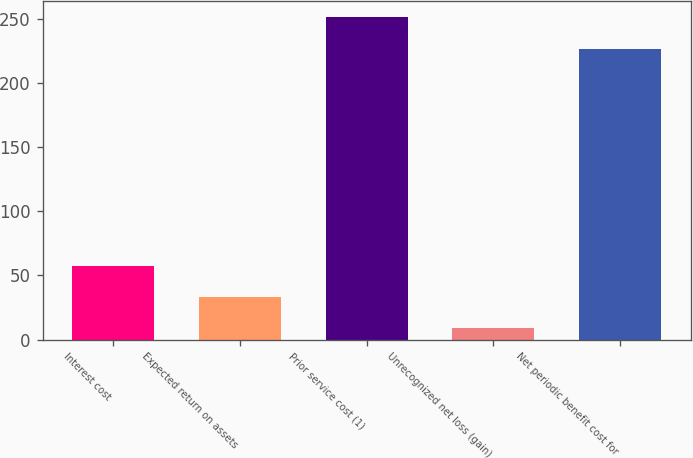Convert chart to OTSL. <chart><loc_0><loc_0><loc_500><loc_500><bar_chart><fcel>Interest cost<fcel>Expected return on assets<fcel>Prior service cost (1)<fcel>Unrecognized net loss (gain)<fcel>Net periodic benefit cost for<nl><fcel>57.4<fcel>33.2<fcel>251<fcel>9<fcel>226<nl></chart> 